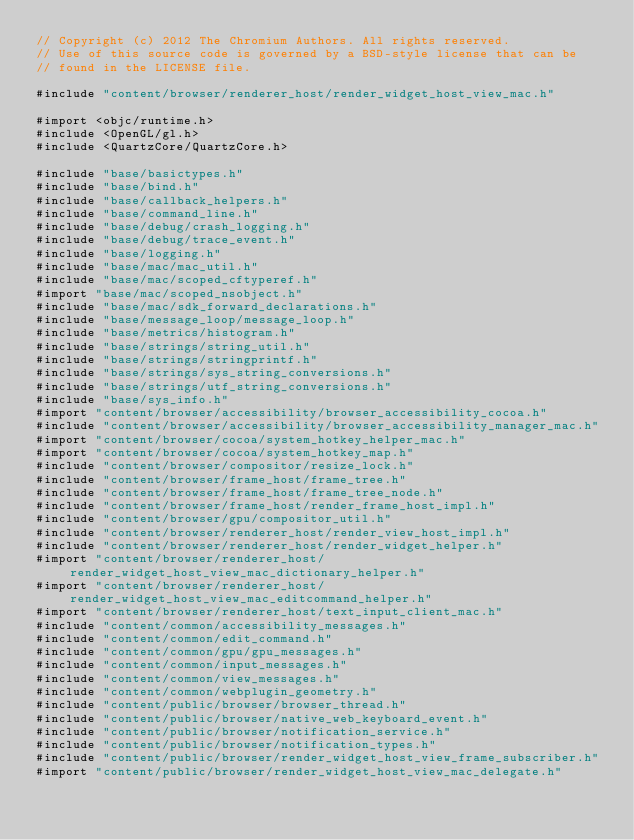<code> <loc_0><loc_0><loc_500><loc_500><_ObjectiveC_>// Copyright (c) 2012 The Chromium Authors. All rights reserved.
// Use of this source code is governed by a BSD-style license that can be
// found in the LICENSE file.

#include "content/browser/renderer_host/render_widget_host_view_mac.h"

#import <objc/runtime.h>
#include <OpenGL/gl.h>
#include <QuartzCore/QuartzCore.h>

#include "base/basictypes.h"
#include "base/bind.h"
#include "base/callback_helpers.h"
#include "base/command_line.h"
#include "base/debug/crash_logging.h"
#include "base/debug/trace_event.h"
#include "base/logging.h"
#include "base/mac/mac_util.h"
#include "base/mac/scoped_cftyperef.h"
#import "base/mac/scoped_nsobject.h"
#include "base/mac/sdk_forward_declarations.h"
#include "base/message_loop/message_loop.h"
#include "base/metrics/histogram.h"
#include "base/strings/string_util.h"
#include "base/strings/stringprintf.h"
#include "base/strings/sys_string_conversions.h"
#include "base/strings/utf_string_conversions.h"
#include "base/sys_info.h"
#import "content/browser/accessibility/browser_accessibility_cocoa.h"
#include "content/browser/accessibility/browser_accessibility_manager_mac.h"
#import "content/browser/cocoa/system_hotkey_helper_mac.h"
#import "content/browser/cocoa/system_hotkey_map.h"
#include "content/browser/compositor/resize_lock.h"
#include "content/browser/frame_host/frame_tree.h"
#include "content/browser/frame_host/frame_tree_node.h"
#include "content/browser/frame_host/render_frame_host_impl.h"
#include "content/browser/gpu/compositor_util.h"
#include "content/browser/renderer_host/render_view_host_impl.h"
#include "content/browser/renderer_host/render_widget_helper.h"
#import "content/browser/renderer_host/render_widget_host_view_mac_dictionary_helper.h"
#import "content/browser/renderer_host/render_widget_host_view_mac_editcommand_helper.h"
#import "content/browser/renderer_host/text_input_client_mac.h"
#include "content/common/accessibility_messages.h"
#include "content/common/edit_command.h"
#include "content/common/gpu/gpu_messages.h"
#include "content/common/input_messages.h"
#include "content/common/view_messages.h"
#include "content/common/webplugin_geometry.h"
#include "content/public/browser/browser_thread.h"
#include "content/public/browser/native_web_keyboard_event.h"
#include "content/public/browser/notification_service.h"
#include "content/public/browser/notification_types.h"
#include "content/public/browser/render_widget_host_view_frame_subscriber.h"
#import "content/public/browser/render_widget_host_view_mac_delegate.h"</code> 